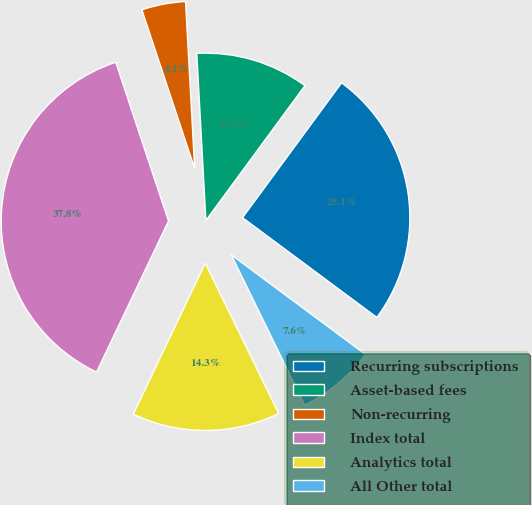<chart> <loc_0><loc_0><loc_500><loc_500><pie_chart><fcel>Recurring subscriptions<fcel>Asset-based fees<fcel>Non-recurring<fcel>Index total<fcel>Analytics total<fcel>All Other total<nl><fcel>25.08%<fcel>10.95%<fcel>4.24%<fcel>37.81%<fcel>14.31%<fcel>7.6%<nl></chart> 